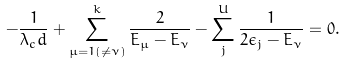Convert formula to latex. <formula><loc_0><loc_0><loc_500><loc_500>- \frac { 1 } { \lambda _ { c } d } + \sum _ { \mu = 1 ( \neq \nu ) } ^ { k } \frac { 2 } { E _ { \mu } - E _ { \nu } } - \sum _ { j } ^ { U } \frac { 1 } { 2 \epsilon _ { j } - E _ { \nu } } = 0 .</formula> 